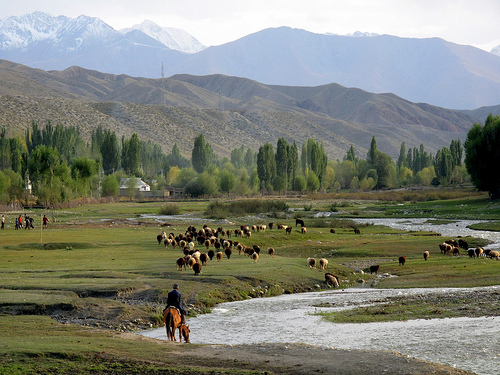<image>
Is there a river next to the grass? Yes. The river is positioned adjacent to the grass, located nearby in the same general area. 